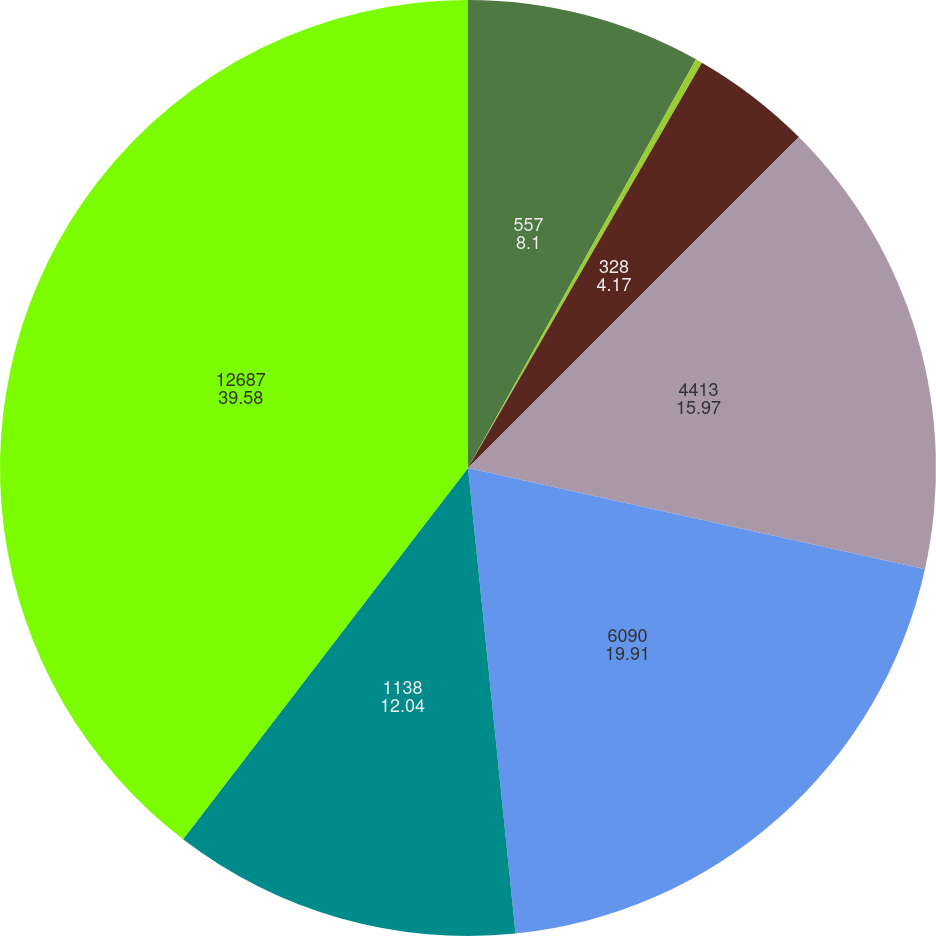Convert chart to OTSL. <chart><loc_0><loc_0><loc_500><loc_500><pie_chart><fcel>557<fcel>127<fcel>328<fcel>4413<fcel>6090<fcel>1138<fcel>12687<nl><fcel>8.1%<fcel>0.23%<fcel>4.17%<fcel>15.97%<fcel>19.91%<fcel>12.04%<fcel>39.58%<nl></chart> 